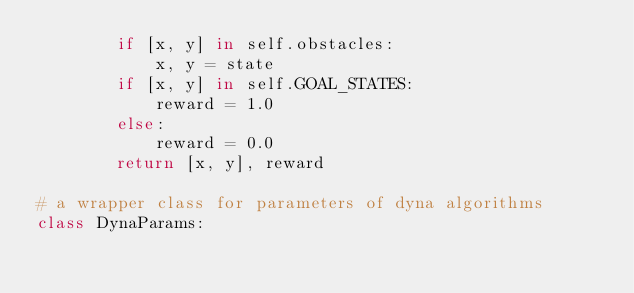Convert code to text. <code><loc_0><loc_0><loc_500><loc_500><_Python_>        if [x, y] in self.obstacles:
            x, y = state
        if [x, y] in self.GOAL_STATES:
            reward = 1.0
        else:
            reward = 0.0
        return [x, y], reward

# a wrapper class for parameters of dyna algorithms
class DynaParams:</code> 